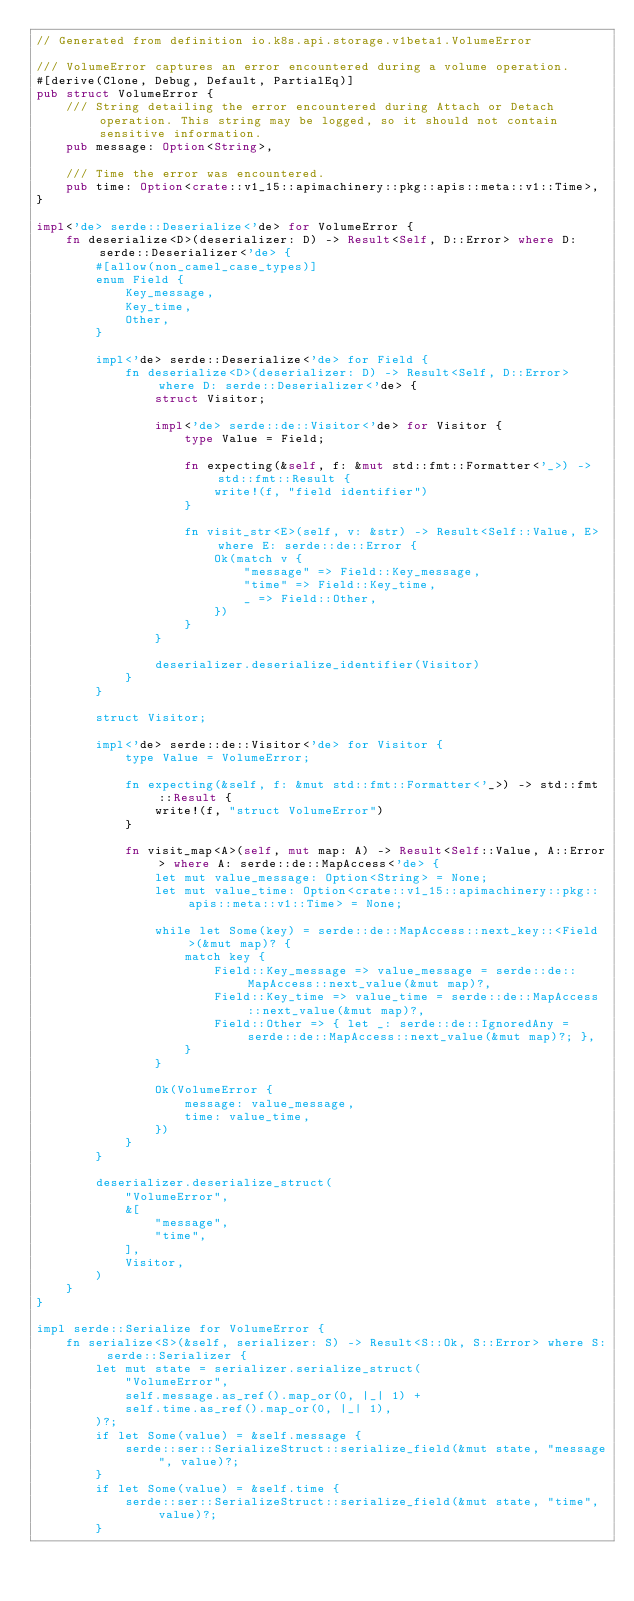Convert code to text. <code><loc_0><loc_0><loc_500><loc_500><_Rust_>// Generated from definition io.k8s.api.storage.v1beta1.VolumeError

/// VolumeError captures an error encountered during a volume operation.
#[derive(Clone, Debug, Default, PartialEq)]
pub struct VolumeError {
    /// String detailing the error encountered during Attach or Detach operation. This string may be logged, so it should not contain sensitive information.
    pub message: Option<String>,

    /// Time the error was encountered.
    pub time: Option<crate::v1_15::apimachinery::pkg::apis::meta::v1::Time>,
}

impl<'de> serde::Deserialize<'de> for VolumeError {
    fn deserialize<D>(deserializer: D) -> Result<Self, D::Error> where D: serde::Deserializer<'de> {
        #[allow(non_camel_case_types)]
        enum Field {
            Key_message,
            Key_time,
            Other,
        }

        impl<'de> serde::Deserialize<'de> for Field {
            fn deserialize<D>(deserializer: D) -> Result<Self, D::Error> where D: serde::Deserializer<'de> {
                struct Visitor;

                impl<'de> serde::de::Visitor<'de> for Visitor {
                    type Value = Field;

                    fn expecting(&self, f: &mut std::fmt::Formatter<'_>) -> std::fmt::Result {
                        write!(f, "field identifier")
                    }

                    fn visit_str<E>(self, v: &str) -> Result<Self::Value, E> where E: serde::de::Error {
                        Ok(match v {
                            "message" => Field::Key_message,
                            "time" => Field::Key_time,
                            _ => Field::Other,
                        })
                    }
                }

                deserializer.deserialize_identifier(Visitor)
            }
        }

        struct Visitor;

        impl<'de> serde::de::Visitor<'de> for Visitor {
            type Value = VolumeError;

            fn expecting(&self, f: &mut std::fmt::Formatter<'_>) -> std::fmt::Result {
                write!(f, "struct VolumeError")
            }

            fn visit_map<A>(self, mut map: A) -> Result<Self::Value, A::Error> where A: serde::de::MapAccess<'de> {
                let mut value_message: Option<String> = None;
                let mut value_time: Option<crate::v1_15::apimachinery::pkg::apis::meta::v1::Time> = None;

                while let Some(key) = serde::de::MapAccess::next_key::<Field>(&mut map)? {
                    match key {
                        Field::Key_message => value_message = serde::de::MapAccess::next_value(&mut map)?,
                        Field::Key_time => value_time = serde::de::MapAccess::next_value(&mut map)?,
                        Field::Other => { let _: serde::de::IgnoredAny = serde::de::MapAccess::next_value(&mut map)?; },
                    }
                }

                Ok(VolumeError {
                    message: value_message,
                    time: value_time,
                })
            }
        }

        deserializer.deserialize_struct(
            "VolumeError",
            &[
                "message",
                "time",
            ],
            Visitor,
        )
    }
}

impl serde::Serialize for VolumeError {
    fn serialize<S>(&self, serializer: S) -> Result<S::Ok, S::Error> where S: serde::Serializer {
        let mut state = serializer.serialize_struct(
            "VolumeError",
            self.message.as_ref().map_or(0, |_| 1) +
            self.time.as_ref().map_or(0, |_| 1),
        )?;
        if let Some(value) = &self.message {
            serde::ser::SerializeStruct::serialize_field(&mut state, "message", value)?;
        }
        if let Some(value) = &self.time {
            serde::ser::SerializeStruct::serialize_field(&mut state, "time", value)?;
        }</code> 